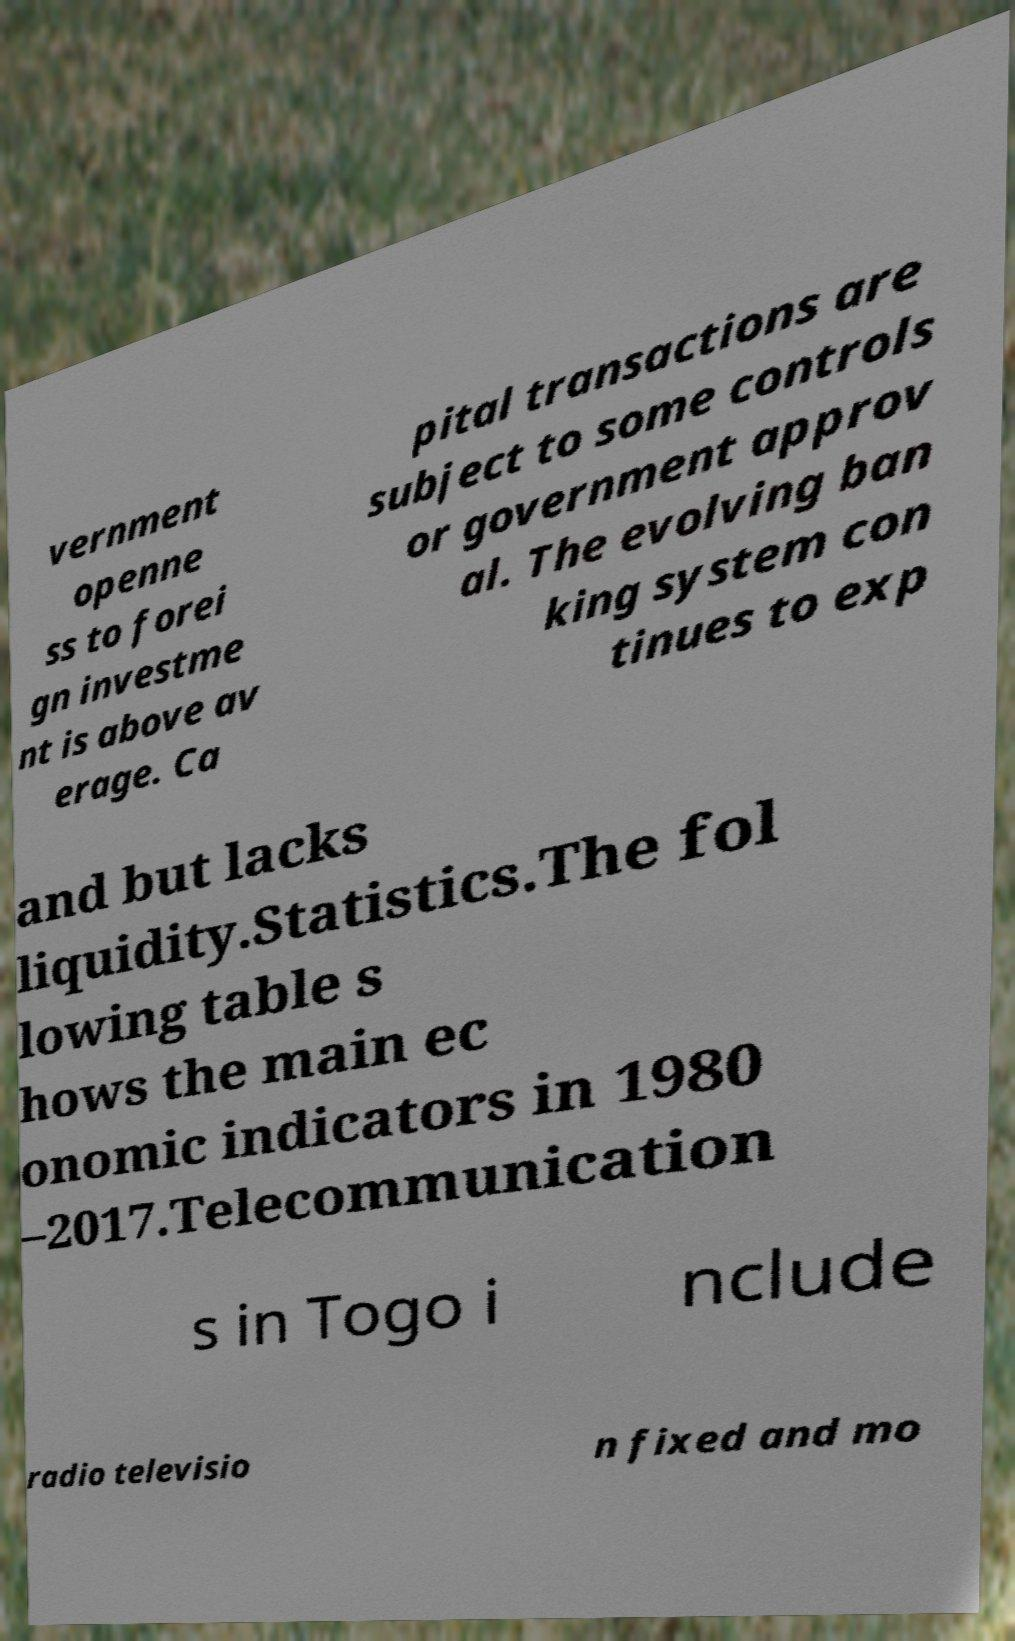Can you read and provide the text displayed in the image?This photo seems to have some interesting text. Can you extract and type it out for me? vernment openne ss to forei gn investme nt is above av erage. Ca pital transactions are subject to some controls or government approv al. The evolving ban king system con tinues to exp and but lacks liquidity.Statistics.The fol lowing table s hows the main ec onomic indicators in 1980 –2017.Telecommunication s in Togo i nclude radio televisio n fixed and mo 